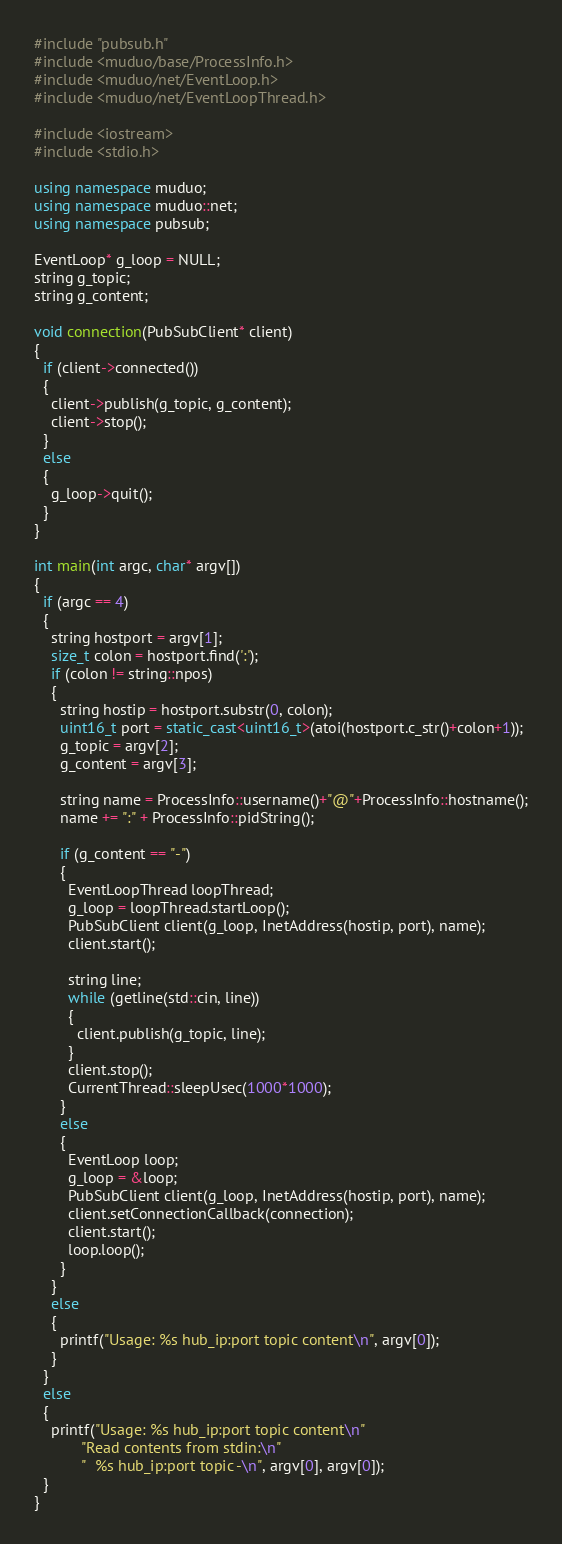<code> <loc_0><loc_0><loc_500><loc_500><_C++_>#include "pubsub.h"
#include <muduo/base/ProcessInfo.h>
#include <muduo/net/EventLoop.h>
#include <muduo/net/EventLoopThread.h>

#include <iostream>
#include <stdio.h>

using namespace muduo;
using namespace muduo::net;
using namespace pubsub;

EventLoop* g_loop = NULL;
string g_topic;
string g_content;

void connection(PubSubClient* client)
{
  if (client->connected())
  {
    client->publish(g_topic, g_content);
    client->stop();
  }
  else
  {
    g_loop->quit();
  }
}

int main(int argc, char* argv[])
{
  if (argc == 4)
  {
    string hostport = argv[1];
    size_t colon = hostport.find(':');
    if (colon != string::npos)
    {
      string hostip = hostport.substr(0, colon);
      uint16_t port = static_cast<uint16_t>(atoi(hostport.c_str()+colon+1));
      g_topic = argv[2];
      g_content = argv[3];

      string name = ProcessInfo::username()+"@"+ProcessInfo::hostname();
      name += ":" + ProcessInfo::pidString();

      if (g_content == "-")
      {
        EventLoopThread loopThread;
        g_loop = loopThread.startLoop();
        PubSubClient client(g_loop, InetAddress(hostip, port), name);
        client.start();

        string line;
        while (getline(std::cin, line))
        {
          client.publish(g_topic, line);
        }
        client.stop();
        CurrentThread::sleepUsec(1000*1000);
      }
      else
      {
        EventLoop loop;
        g_loop = &loop;
        PubSubClient client(g_loop, InetAddress(hostip, port), name);
        client.setConnectionCallback(connection);
        client.start();
        loop.loop();
      }
    }
    else
    {
      printf("Usage: %s hub_ip:port topic content\n", argv[0]);
    }
  }
  else
  {
    printf("Usage: %s hub_ip:port topic content\n"
           "Read contents from stdin:\n"
           "  %s hub_ip:port topic -\n", argv[0], argv[0]);
  }
}
</code> 